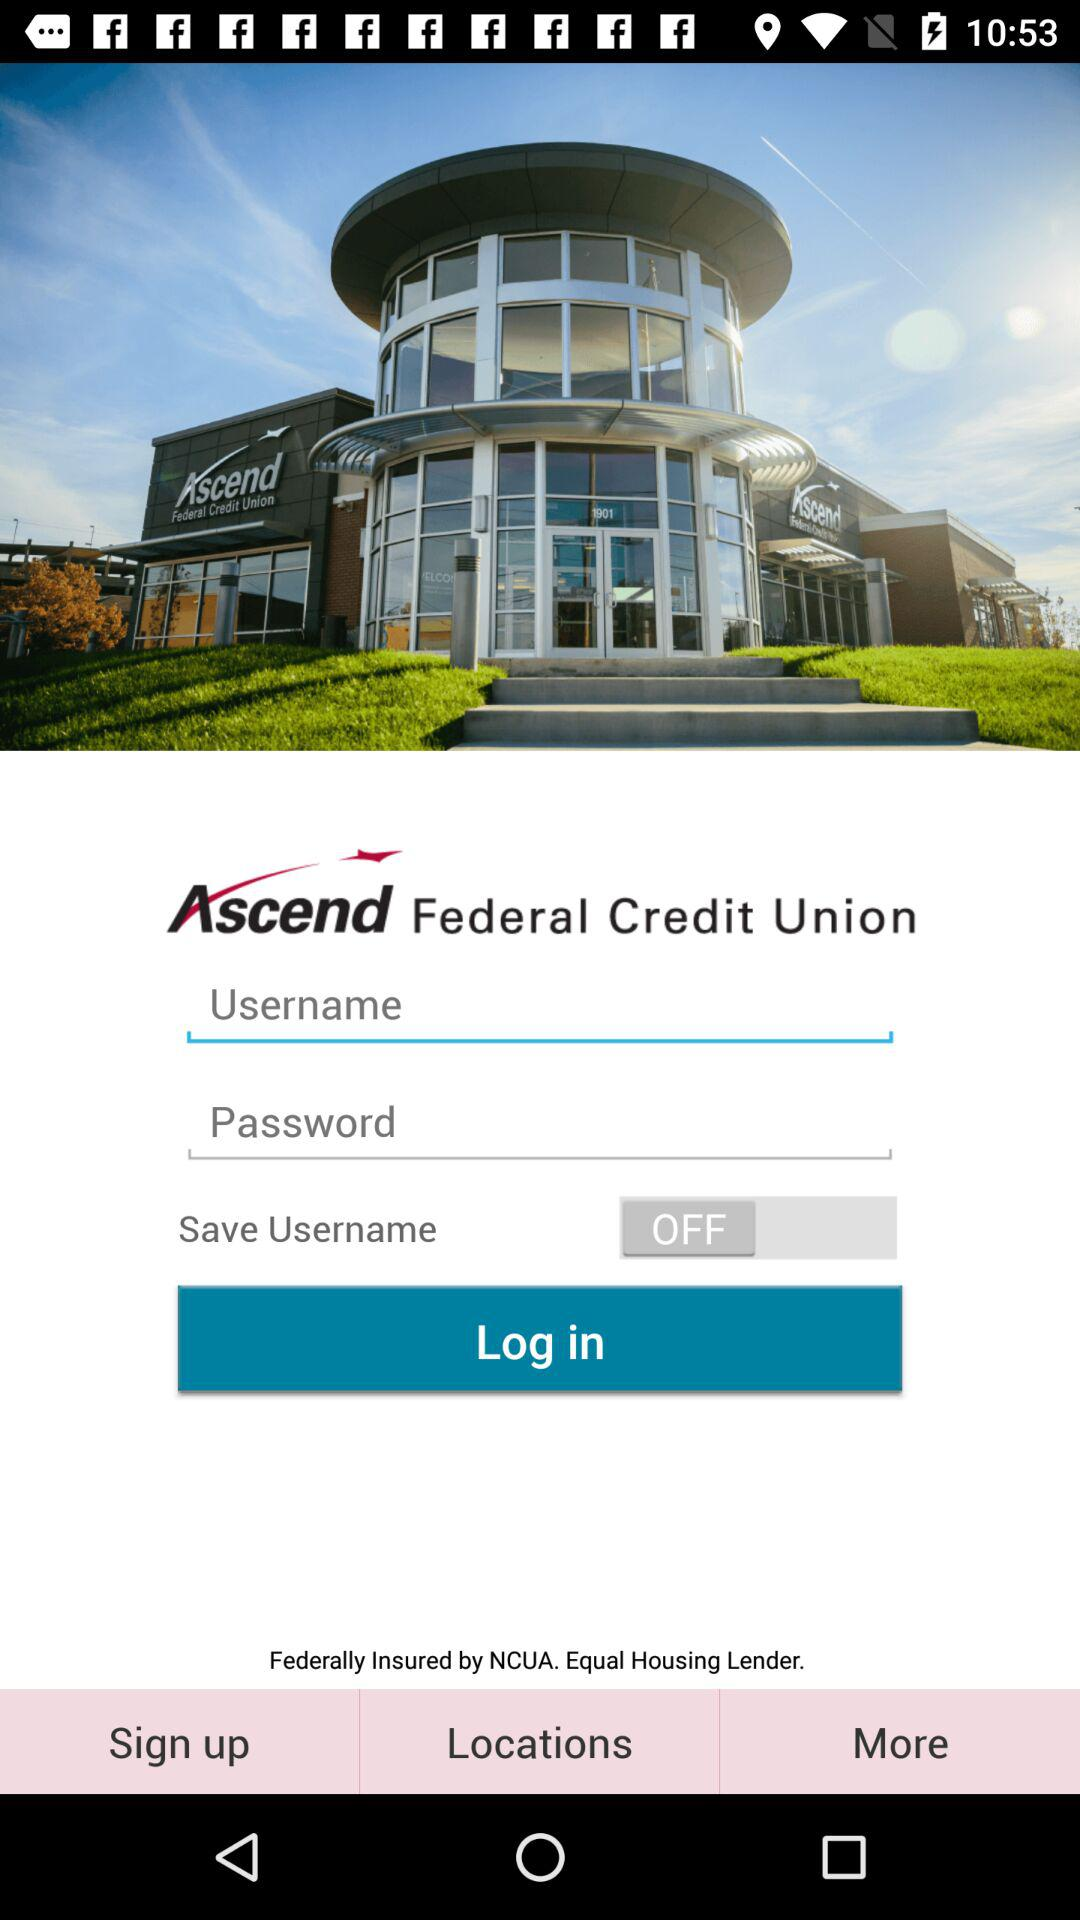What is the app name? The app name is "Ascend Federal Credit Union". 